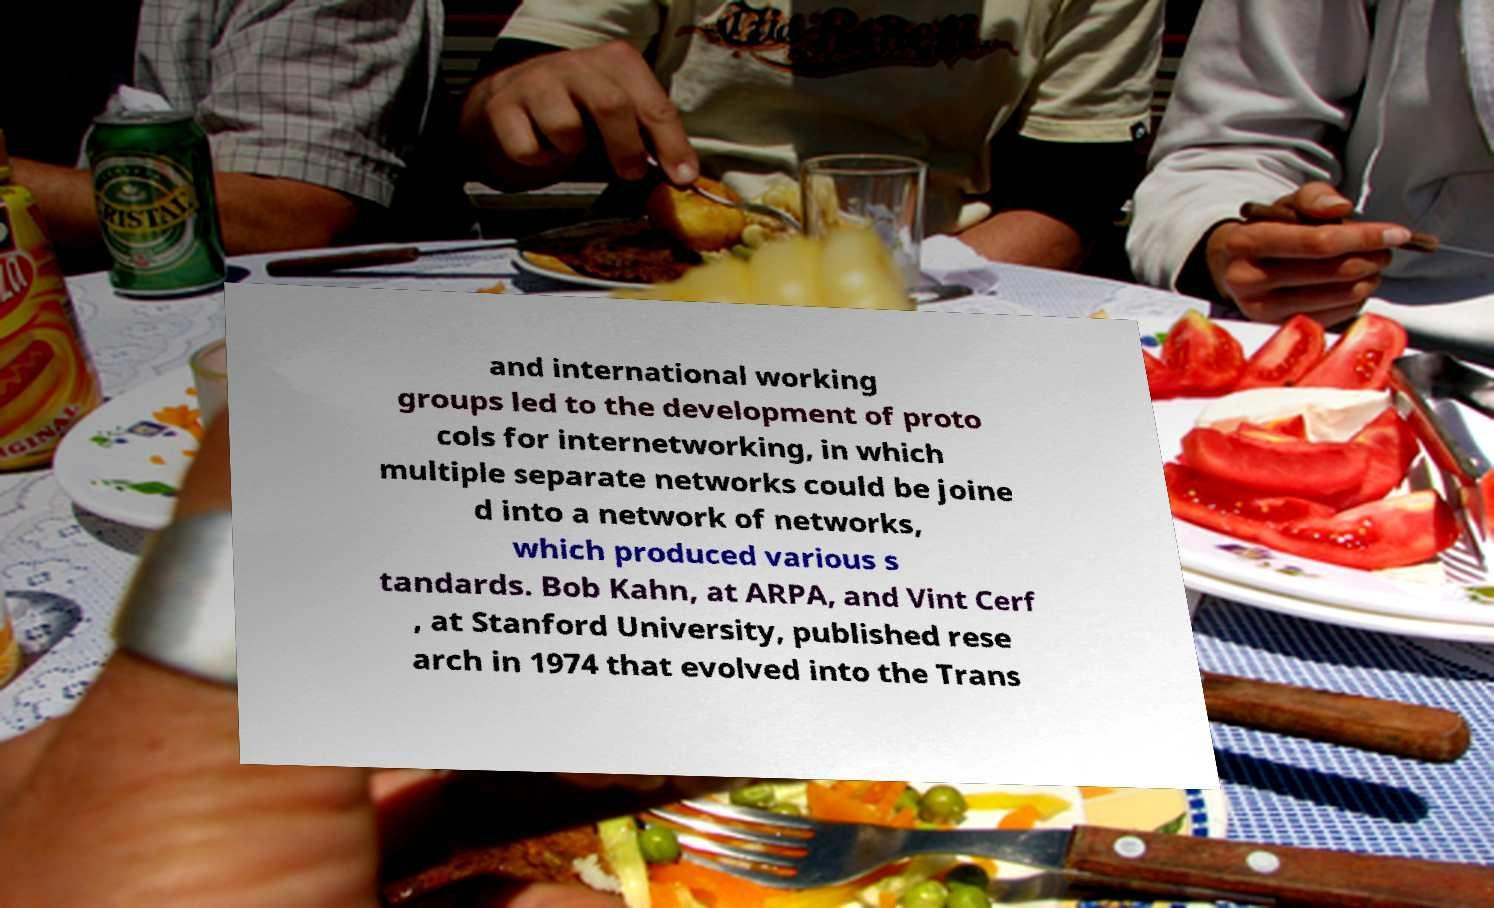Please read and relay the text visible in this image. What does it say? and international working groups led to the development of proto cols for internetworking, in which multiple separate networks could be joine d into a network of networks, which produced various s tandards. Bob Kahn, at ARPA, and Vint Cerf , at Stanford University, published rese arch in 1974 that evolved into the Trans 